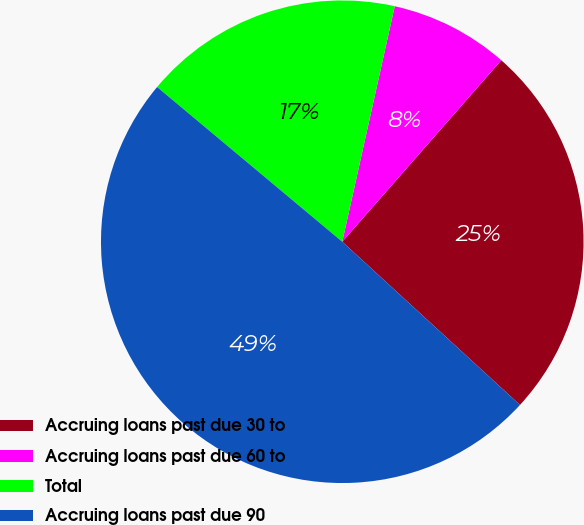Convert chart. <chart><loc_0><loc_0><loc_500><loc_500><pie_chart><fcel>Accruing loans past due 30 to<fcel>Accruing loans past due 60 to<fcel>Total<fcel>Accruing loans past due 90<nl><fcel>25.37%<fcel>7.96%<fcel>17.41%<fcel>49.25%<nl></chart> 